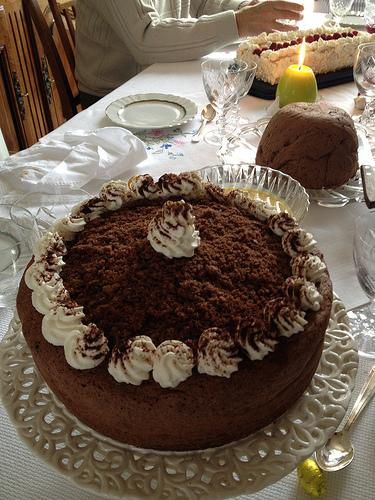Describe the ambiance of the dinner setting, focusing on the overall arrangement of items on the table. The table displays a neatly arranged dining setting with a round chocolate cake, a burning candle, clear glasses, and silverware, fitting for a special occasion. Write a brief description of the cake's design and any additional adornments. The cake features a layer of vanilla frosting, brown crumbles, white icing, and raspberries on top, creating an attractive contrast of colors. What is the centerpiece of the image, and what does it contain? The centerpiece is a round chocolate cake with whip cream, white icing, and brown crumbles on top, accompanied by raspberries. Identify the type of cake in the image and describe its appearance. A chocolate cake with vanilla frosting, topped with brown crumbles and white decorative icing, surrounded by raspberries. Identify the dominant color in the image, and explain how it contributes to the composition. Brown, as the dominant color, is present in the cake and table elements, which creates a warm and inviting atmosphere in the image. Provide a detailed description of any plates and utensils present in the image. A round white serving plate holds the cake, accompanied by a small white dessert plate, and two silver spoons—one beside the plate and another on the table. Describe any illumination sources in the picture and their effect on the scene. A lime green candle is lit, creating a warm, intimate atmosphere around the cake and table setting. Examine and describe the tablecloth's color and any patterns it may have. The tablecloth is white in color with floral embroidery, adding elegance and sophistication to the table setting. Examine the table setting and list any additional items present. There are two clear glasses, a white napkin, a silver spoon, a bright green candle, and a chocolate egg in a gold foil wrapper. Describe the inclusion and arrangement of any fruit or toppings on the cake in the image. The cake has brown crumbles scattered on top alongside white icing, with raspberries placed around its edge. 